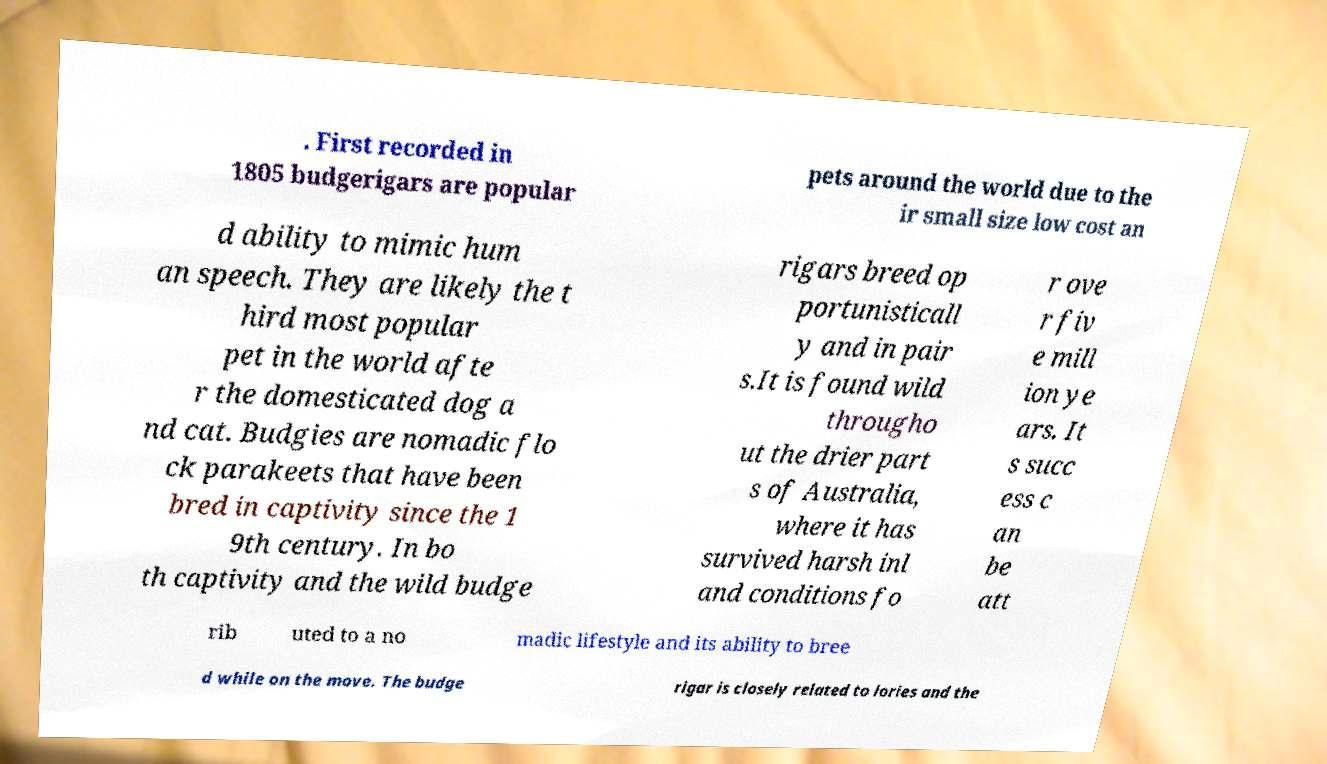Please read and relay the text visible in this image. What does it say? . First recorded in 1805 budgerigars are popular pets around the world due to the ir small size low cost an d ability to mimic hum an speech. They are likely the t hird most popular pet in the world afte r the domesticated dog a nd cat. Budgies are nomadic flo ck parakeets that have been bred in captivity since the 1 9th century. In bo th captivity and the wild budge rigars breed op portunisticall y and in pair s.It is found wild througho ut the drier part s of Australia, where it has survived harsh inl and conditions fo r ove r fiv e mill ion ye ars. It s succ ess c an be att rib uted to a no madic lifestyle and its ability to bree d while on the move. The budge rigar is closely related to lories and the 